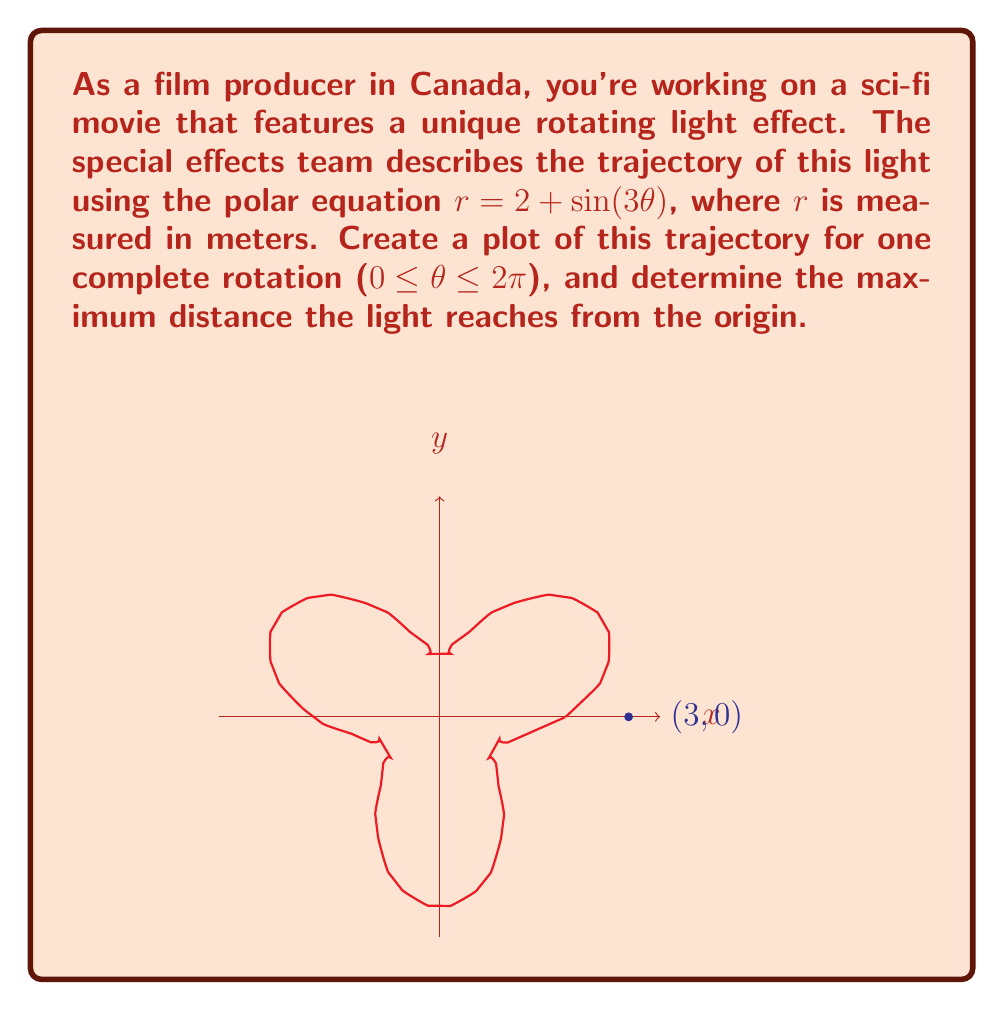Give your solution to this math problem. To solve this problem, let's follow these steps:

1) The polar equation given is $r = 2 + \sin(3\theta)$. This represents a curve that oscillates around a circle of radius 2, with three lobes due to the $\sin(3\theta)$ term.

2) To find the maximum distance from the origin, we need to find the maximum value of $r$:

   $r_{max} = 2 + \max(\sin(3\theta))$

3) We know that the maximum value of sine is 1, so:

   $r_{max} = 2 + 1 = 3$

4) This maximum occurs when $\sin(3\theta) = 1$, which happens when $3\theta = \frac{\pi}{2}, \frac{5\pi}{2}, \frac{9\pi}{2}$, etc.

5) In the context of one complete rotation ($0 \leq \theta \leq 2\pi$), these maxima occur at:

   $\theta = \frac{\pi}{6}, \frac{5\pi}{6}, \frac{3\pi}{2}$

6) The plot shows the trajectory for one complete rotation. The curve starts at $r = 2$ when $\theta = 0$, then oscillates between $r = 1$ and $r = 3$ as it completes three lobes over the full rotation.

7) The blue dot on the plot indicates the point (3,0), which is one of the points where the light reaches its maximum distance from the origin.
Answer: Maximum distance: 3 meters 